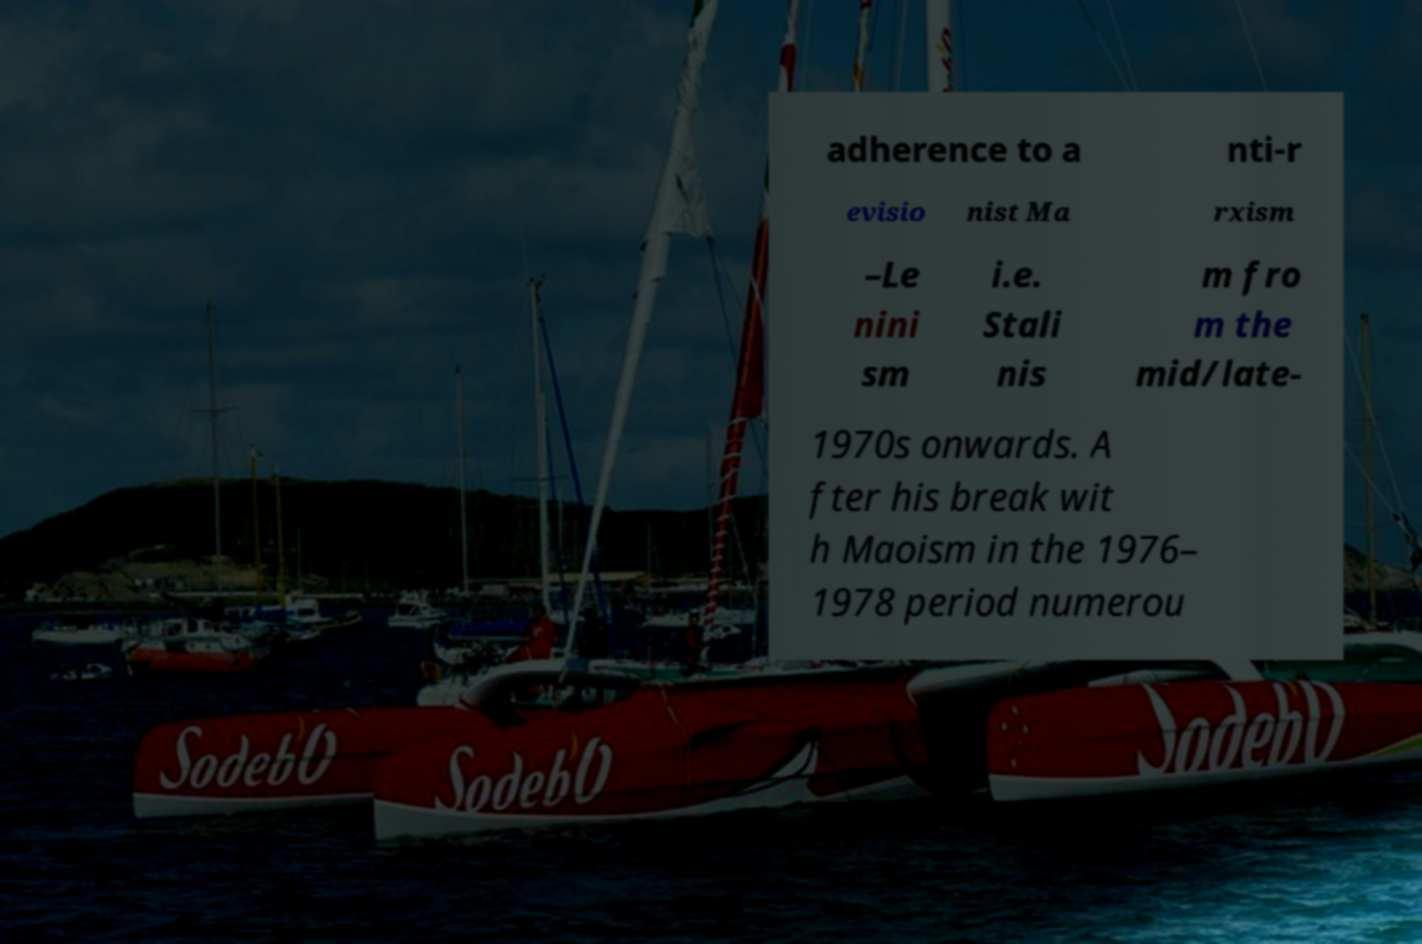Please read and relay the text visible in this image. What does it say? adherence to a nti-r evisio nist Ma rxism –Le nini sm i.e. Stali nis m fro m the mid/late- 1970s onwards. A fter his break wit h Maoism in the 1976– 1978 period numerou 